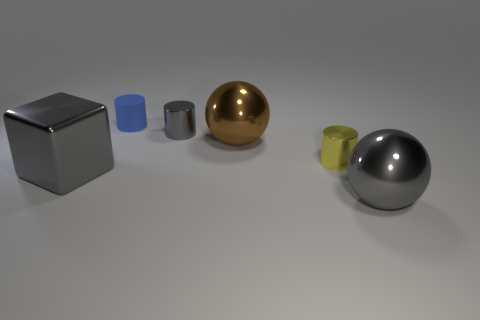Subtract all gray cylinders. How many cylinders are left? 2 Add 4 metal cylinders. How many objects exist? 10 Subtract 1 gray balls. How many objects are left? 5 Subtract all cubes. How many objects are left? 5 Subtract 1 cylinders. How many cylinders are left? 2 Subtract all green cylinders. Subtract all yellow cubes. How many cylinders are left? 3 Subtract all brown spheres. How many yellow blocks are left? 0 Subtract all blue matte things. Subtract all gray blocks. How many objects are left? 4 Add 3 large brown metal things. How many large brown metal things are left? 4 Add 1 gray spheres. How many gray spheres exist? 2 